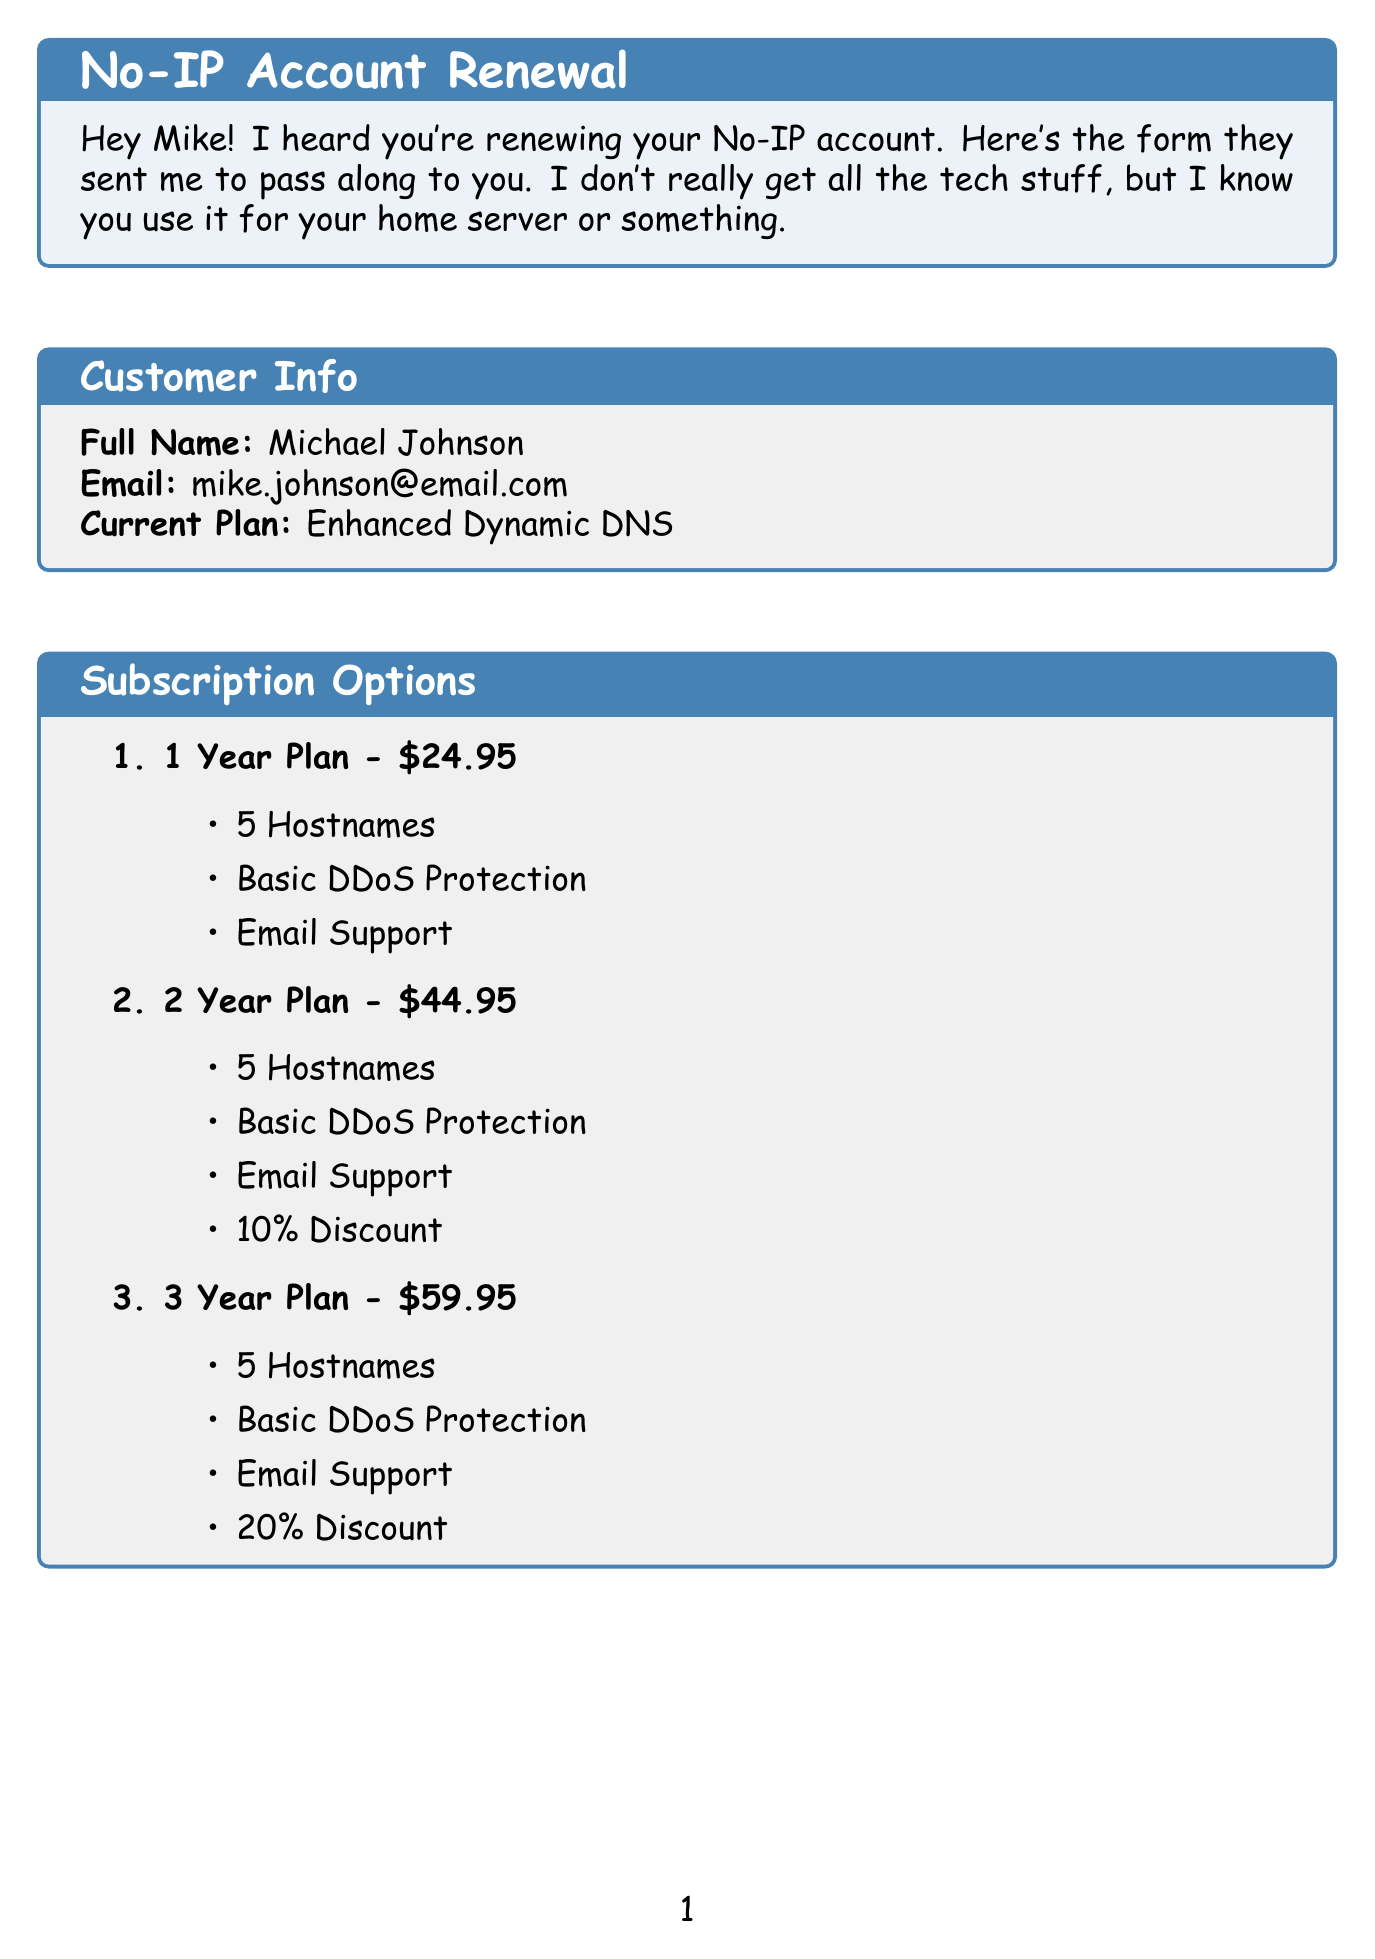What is the total duration for the 2 Year Plan? The duration for the 2 Year Plan is specified in the subscription options section.
Answer: 2 Years What is the price of the 1 Year Plan? The price for the 1 Year Plan is listed in the subscription options section.
Answer: $24.95 How many hostnames are included in the subscription options? The number of hostnames is mentioned in all the subscription options.
Answer: 5 Hostnames What is the discount for the 3 Year Plan? The discount for the 3 Year Plan is stated in the subscription options section.
Answer: 20% Discount Which payment method is NOT mentioned? The payment methods are clearly listed in the document, and any option not in the list can be identified.
Answer: None If Mike chooses Managed DNS, how much will it cost? The price for the Managed DNS service is provided in the additional services section.
Answer: $14.95/year Who can Mike contact for customer support? The customer support contact information is mentioned in the document.
Answer: 1-800-NO-IP-HELP What additional service secures the connection with HTTPS? The description for the additional services states which one secures the connection.
Answer: SSL Certificate What is the current plan Mike has? The current plan is detailed in the customer info section at the beginning of the document.
Answer: Enhanced Dynamic DNS 